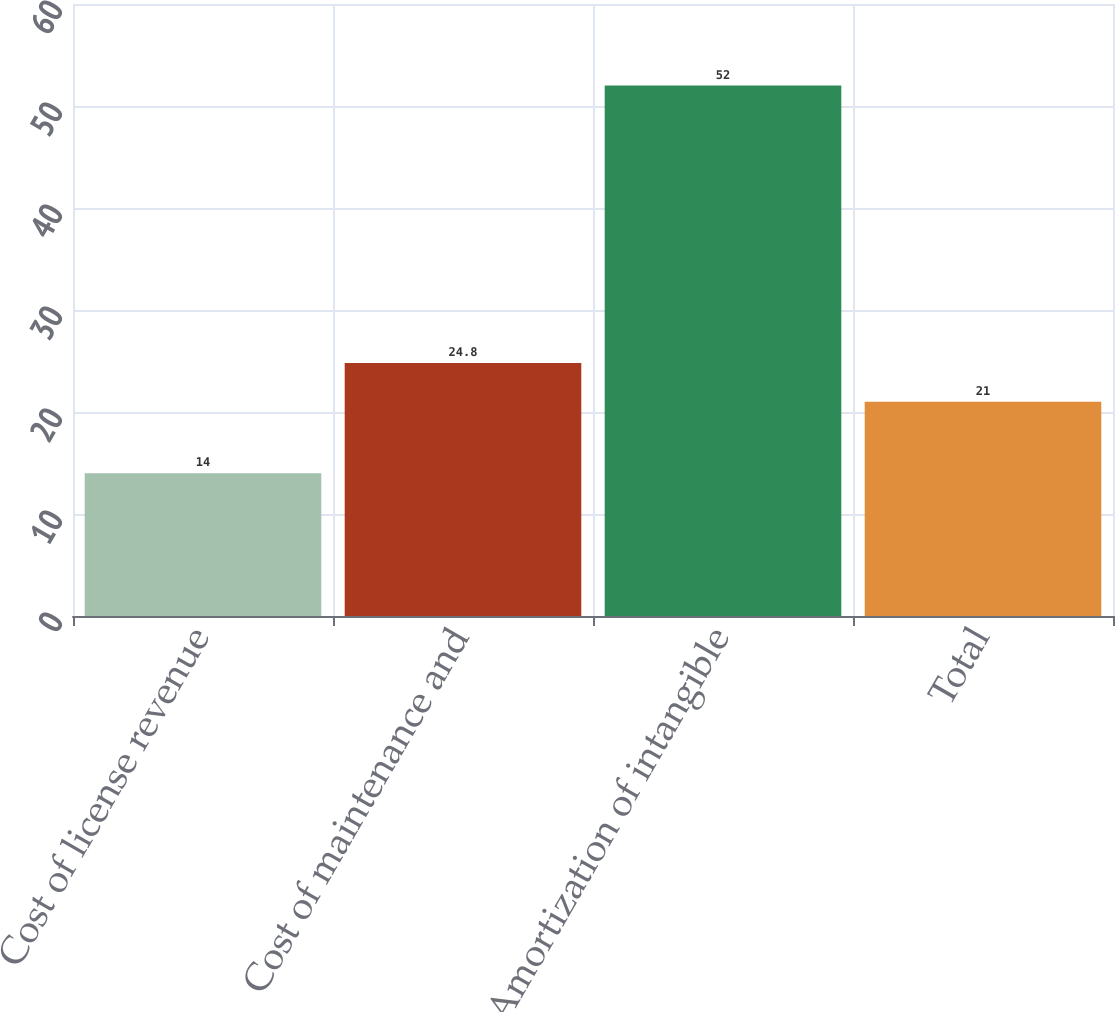<chart> <loc_0><loc_0><loc_500><loc_500><bar_chart><fcel>Cost of license revenue<fcel>Cost of maintenance and<fcel>Amortization of intangible<fcel>Total<nl><fcel>14<fcel>24.8<fcel>52<fcel>21<nl></chart> 